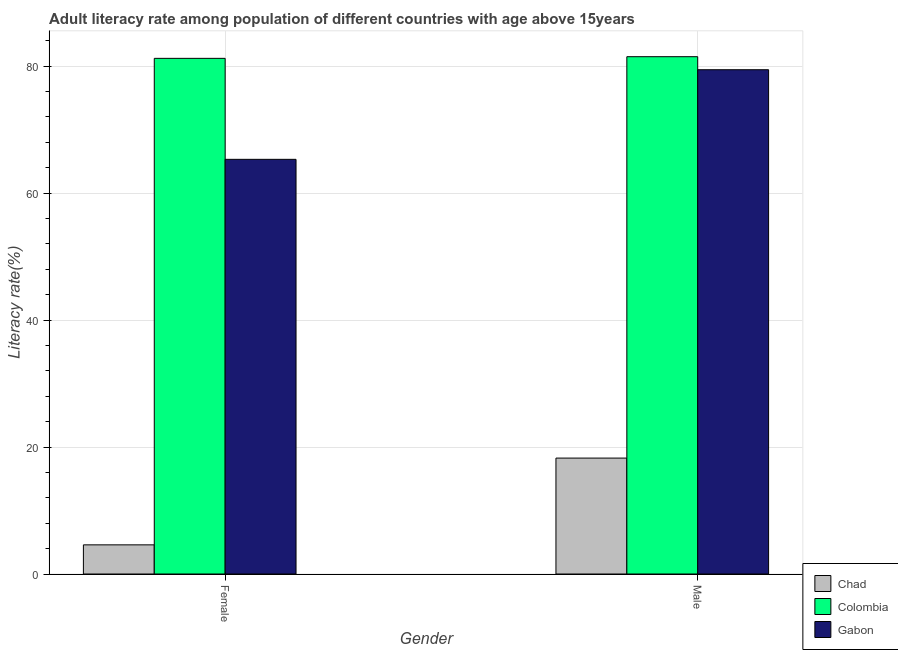How many groups of bars are there?
Make the answer very short. 2. Are the number of bars on each tick of the X-axis equal?
Your answer should be compact. Yes. How many bars are there on the 2nd tick from the left?
Make the answer very short. 3. What is the female adult literacy rate in Gabon?
Your response must be concise. 65.33. Across all countries, what is the maximum female adult literacy rate?
Provide a succinct answer. 81.24. Across all countries, what is the minimum female adult literacy rate?
Keep it short and to the point. 4.59. In which country was the male adult literacy rate minimum?
Give a very brief answer. Chad. What is the total female adult literacy rate in the graph?
Ensure brevity in your answer.  151.15. What is the difference between the male adult literacy rate in Gabon and that in Chad?
Give a very brief answer. 61.18. What is the difference between the male adult literacy rate in Chad and the female adult literacy rate in Gabon?
Offer a very short reply. -47.07. What is the average female adult literacy rate per country?
Your answer should be compact. 50.38. What is the difference between the female adult literacy rate and male adult literacy rate in Gabon?
Keep it short and to the point. -14.12. What is the ratio of the male adult literacy rate in Chad to that in Gabon?
Offer a terse response. 0.23. Is the female adult literacy rate in Chad less than that in Gabon?
Provide a succinct answer. Yes. In how many countries, is the female adult literacy rate greater than the average female adult literacy rate taken over all countries?
Provide a short and direct response. 2. What does the 1st bar from the left in Female represents?
Provide a short and direct response. Chad. What does the 3rd bar from the right in Male represents?
Provide a short and direct response. Chad. How many bars are there?
Your answer should be very brief. 6. Are all the bars in the graph horizontal?
Give a very brief answer. No. How many countries are there in the graph?
Your response must be concise. 3. Are the values on the major ticks of Y-axis written in scientific E-notation?
Ensure brevity in your answer.  No. Does the graph contain grids?
Your response must be concise. Yes. What is the title of the graph?
Offer a very short reply. Adult literacy rate among population of different countries with age above 15years. Does "Mali" appear as one of the legend labels in the graph?
Make the answer very short. No. What is the label or title of the Y-axis?
Keep it short and to the point. Literacy rate(%). What is the Literacy rate(%) of Chad in Female?
Offer a very short reply. 4.59. What is the Literacy rate(%) of Colombia in Female?
Your answer should be very brief. 81.24. What is the Literacy rate(%) in Gabon in Female?
Your answer should be compact. 65.33. What is the Literacy rate(%) in Chad in Male?
Provide a succinct answer. 18.26. What is the Literacy rate(%) of Colombia in Male?
Your answer should be very brief. 81.5. What is the Literacy rate(%) in Gabon in Male?
Ensure brevity in your answer.  79.44. Across all Gender, what is the maximum Literacy rate(%) of Chad?
Provide a short and direct response. 18.26. Across all Gender, what is the maximum Literacy rate(%) of Colombia?
Your answer should be compact. 81.5. Across all Gender, what is the maximum Literacy rate(%) in Gabon?
Give a very brief answer. 79.44. Across all Gender, what is the minimum Literacy rate(%) in Chad?
Your response must be concise. 4.59. Across all Gender, what is the minimum Literacy rate(%) of Colombia?
Give a very brief answer. 81.24. Across all Gender, what is the minimum Literacy rate(%) of Gabon?
Offer a terse response. 65.33. What is the total Literacy rate(%) in Chad in the graph?
Your answer should be very brief. 22.85. What is the total Literacy rate(%) in Colombia in the graph?
Your answer should be compact. 162.73. What is the total Literacy rate(%) in Gabon in the graph?
Provide a succinct answer. 144.77. What is the difference between the Literacy rate(%) of Chad in Female and that in Male?
Your answer should be very brief. -13.67. What is the difference between the Literacy rate(%) in Colombia in Female and that in Male?
Offer a terse response. -0.26. What is the difference between the Literacy rate(%) of Gabon in Female and that in Male?
Give a very brief answer. -14.12. What is the difference between the Literacy rate(%) of Chad in Female and the Literacy rate(%) of Colombia in Male?
Your answer should be very brief. -76.91. What is the difference between the Literacy rate(%) of Chad in Female and the Literacy rate(%) of Gabon in Male?
Give a very brief answer. -74.85. What is the difference between the Literacy rate(%) in Colombia in Female and the Literacy rate(%) in Gabon in Male?
Your answer should be very brief. 1.79. What is the average Literacy rate(%) in Chad per Gender?
Give a very brief answer. 11.43. What is the average Literacy rate(%) in Colombia per Gender?
Make the answer very short. 81.37. What is the average Literacy rate(%) in Gabon per Gender?
Offer a terse response. 72.39. What is the difference between the Literacy rate(%) in Chad and Literacy rate(%) in Colombia in Female?
Provide a short and direct response. -76.64. What is the difference between the Literacy rate(%) in Chad and Literacy rate(%) in Gabon in Female?
Your response must be concise. -60.73. What is the difference between the Literacy rate(%) of Colombia and Literacy rate(%) of Gabon in Female?
Keep it short and to the point. 15.91. What is the difference between the Literacy rate(%) in Chad and Literacy rate(%) in Colombia in Male?
Make the answer very short. -63.24. What is the difference between the Literacy rate(%) in Chad and Literacy rate(%) in Gabon in Male?
Make the answer very short. -61.18. What is the difference between the Literacy rate(%) in Colombia and Literacy rate(%) in Gabon in Male?
Offer a terse response. 2.05. What is the ratio of the Literacy rate(%) in Chad in Female to that in Male?
Your answer should be very brief. 0.25. What is the ratio of the Literacy rate(%) of Colombia in Female to that in Male?
Your answer should be compact. 1. What is the ratio of the Literacy rate(%) of Gabon in Female to that in Male?
Your answer should be compact. 0.82. What is the difference between the highest and the second highest Literacy rate(%) of Chad?
Offer a very short reply. 13.67. What is the difference between the highest and the second highest Literacy rate(%) of Colombia?
Your answer should be very brief. 0.26. What is the difference between the highest and the second highest Literacy rate(%) of Gabon?
Give a very brief answer. 14.12. What is the difference between the highest and the lowest Literacy rate(%) in Chad?
Offer a very short reply. 13.67. What is the difference between the highest and the lowest Literacy rate(%) in Colombia?
Make the answer very short. 0.26. What is the difference between the highest and the lowest Literacy rate(%) in Gabon?
Provide a succinct answer. 14.12. 